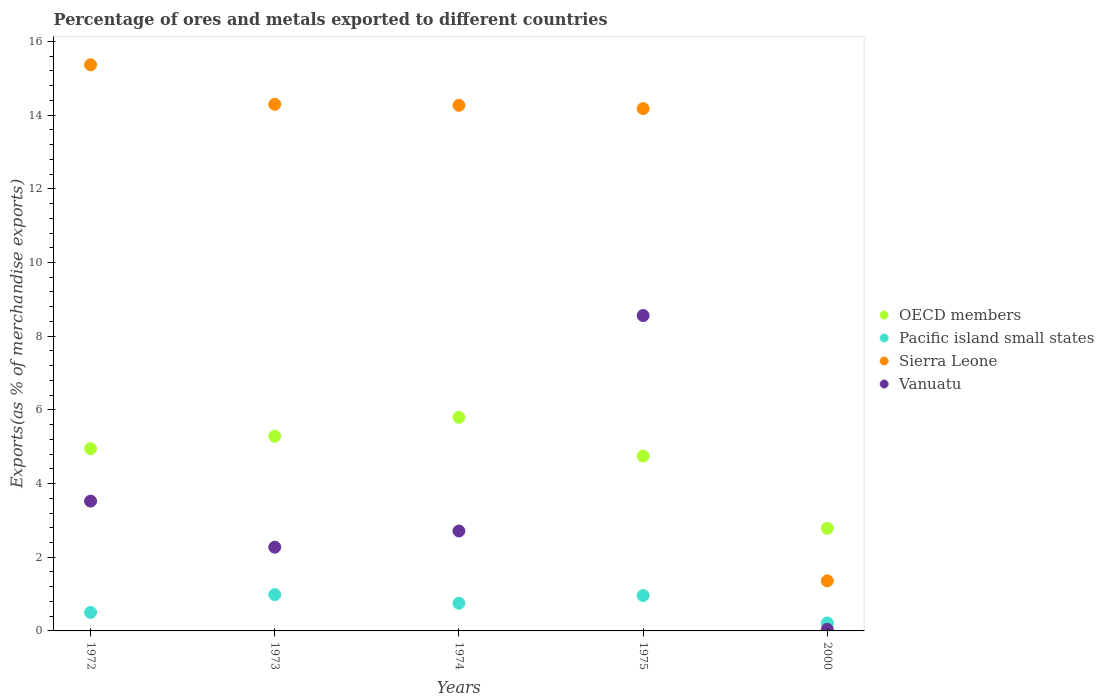How many different coloured dotlines are there?
Make the answer very short. 4. Is the number of dotlines equal to the number of legend labels?
Offer a very short reply. Yes. What is the percentage of exports to different countries in Pacific island small states in 1975?
Offer a very short reply. 0.96. Across all years, what is the maximum percentage of exports to different countries in OECD members?
Provide a succinct answer. 5.8. Across all years, what is the minimum percentage of exports to different countries in Vanuatu?
Your answer should be compact. 0.04. In which year was the percentage of exports to different countries in Vanuatu maximum?
Provide a succinct answer. 1975. In which year was the percentage of exports to different countries in OECD members minimum?
Offer a terse response. 2000. What is the total percentage of exports to different countries in Sierra Leone in the graph?
Give a very brief answer. 59.46. What is the difference between the percentage of exports to different countries in Vanuatu in 1972 and that in 1974?
Your response must be concise. 0.81. What is the difference between the percentage of exports to different countries in Vanuatu in 1975 and the percentage of exports to different countries in Sierra Leone in 2000?
Make the answer very short. 7.2. What is the average percentage of exports to different countries in Sierra Leone per year?
Your answer should be very brief. 11.89. In the year 1973, what is the difference between the percentage of exports to different countries in Vanuatu and percentage of exports to different countries in Sierra Leone?
Keep it short and to the point. -12.02. In how many years, is the percentage of exports to different countries in Pacific island small states greater than 11.6 %?
Ensure brevity in your answer.  0. What is the ratio of the percentage of exports to different countries in Sierra Leone in 1973 to that in 1974?
Give a very brief answer. 1. Is the percentage of exports to different countries in Pacific island small states in 1973 less than that in 1974?
Your answer should be very brief. No. What is the difference between the highest and the second highest percentage of exports to different countries in Vanuatu?
Offer a very short reply. 5.04. What is the difference between the highest and the lowest percentage of exports to different countries in Pacific island small states?
Keep it short and to the point. 0.77. Is the sum of the percentage of exports to different countries in Pacific island small states in 1973 and 1974 greater than the maximum percentage of exports to different countries in Vanuatu across all years?
Give a very brief answer. No. Is the percentage of exports to different countries in Pacific island small states strictly greater than the percentage of exports to different countries in Sierra Leone over the years?
Keep it short and to the point. No. Is the percentage of exports to different countries in OECD members strictly less than the percentage of exports to different countries in Pacific island small states over the years?
Provide a short and direct response. No. How many dotlines are there?
Provide a short and direct response. 4. How many years are there in the graph?
Give a very brief answer. 5. What is the difference between two consecutive major ticks on the Y-axis?
Make the answer very short. 2. What is the title of the graph?
Provide a succinct answer. Percentage of ores and metals exported to different countries. Does "Pacific island small states" appear as one of the legend labels in the graph?
Keep it short and to the point. Yes. What is the label or title of the X-axis?
Your answer should be compact. Years. What is the label or title of the Y-axis?
Offer a terse response. Exports(as % of merchandise exports). What is the Exports(as % of merchandise exports) in OECD members in 1972?
Your answer should be compact. 4.95. What is the Exports(as % of merchandise exports) in Pacific island small states in 1972?
Give a very brief answer. 0.5. What is the Exports(as % of merchandise exports) of Sierra Leone in 1972?
Your answer should be compact. 15.37. What is the Exports(as % of merchandise exports) of Vanuatu in 1972?
Offer a very short reply. 3.52. What is the Exports(as % of merchandise exports) of OECD members in 1973?
Ensure brevity in your answer.  5.28. What is the Exports(as % of merchandise exports) in Pacific island small states in 1973?
Your response must be concise. 0.99. What is the Exports(as % of merchandise exports) in Sierra Leone in 1973?
Make the answer very short. 14.29. What is the Exports(as % of merchandise exports) of Vanuatu in 1973?
Make the answer very short. 2.27. What is the Exports(as % of merchandise exports) of OECD members in 1974?
Give a very brief answer. 5.8. What is the Exports(as % of merchandise exports) of Pacific island small states in 1974?
Your response must be concise. 0.75. What is the Exports(as % of merchandise exports) of Sierra Leone in 1974?
Provide a short and direct response. 14.27. What is the Exports(as % of merchandise exports) in Vanuatu in 1974?
Ensure brevity in your answer.  2.71. What is the Exports(as % of merchandise exports) in OECD members in 1975?
Ensure brevity in your answer.  4.74. What is the Exports(as % of merchandise exports) of Pacific island small states in 1975?
Provide a short and direct response. 0.96. What is the Exports(as % of merchandise exports) in Sierra Leone in 1975?
Provide a succinct answer. 14.18. What is the Exports(as % of merchandise exports) in Vanuatu in 1975?
Offer a very short reply. 8.56. What is the Exports(as % of merchandise exports) of OECD members in 2000?
Provide a short and direct response. 2.78. What is the Exports(as % of merchandise exports) in Pacific island small states in 2000?
Make the answer very short. 0.22. What is the Exports(as % of merchandise exports) in Sierra Leone in 2000?
Ensure brevity in your answer.  1.36. What is the Exports(as % of merchandise exports) in Vanuatu in 2000?
Your answer should be compact. 0.04. Across all years, what is the maximum Exports(as % of merchandise exports) of OECD members?
Offer a terse response. 5.8. Across all years, what is the maximum Exports(as % of merchandise exports) in Pacific island small states?
Ensure brevity in your answer.  0.99. Across all years, what is the maximum Exports(as % of merchandise exports) in Sierra Leone?
Your response must be concise. 15.37. Across all years, what is the maximum Exports(as % of merchandise exports) of Vanuatu?
Your answer should be compact. 8.56. Across all years, what is the minimum Exports(as % of merchandise exports) in OECD members?
Keep it short and to the point. 2.78. Across all years, what is the minimum Exports(as % of merchandise exports) of Pacific island small states?
Offer a terse response. 0.22. Across all years, what is the minimum Exports(as % of merchandise exports) in Sierra Leone?
Make the answer very short. 1.36. Across all years, what is the minimum Exports(as % of merchandise exports) in Vanuatu?
Offer a terse response. 0.04. What is the total Exports(as % of merchandise exports) of OECD members in the graph?
Give a very brief answer. 23.56. What is the total Exports(as % of merchandise exports) in Pacific island small states in the graph?
Offer a terse response. 3.41. What is the total Exports(as % of merchandise exports) in Sierra Leone in the graph?
Your response must be concise. 59.46. What is the total Exports(as % of merchandise exports) of Vanuatu in the graph?
Provide a succinct answer. 17.11. What is the difference between the Exports(as % of merchandise exports) in OECD members in 1972 and that in 1973?
Your response must be concise. -0.34. What is the difference between the Exports(as % of merchandise exports) in Pacific island small states in 1972 and that in 1973?
Keep it short and to the point. -0.48. What is the difference between the Exports(as % of merchandise exports) of Sierra Leone in 1972 and that in 1973?
Keep it short and to the point. 1.07. What is the difference between the Exports(as % of merchandise exports) in Vanuatu in 1972 and that in 1973?
Offer a terse response. 1.25. What is the difference between the Exports(as % of merchandise exports) of OECD members in 1972 and that in 1974?
Keep it short and to the point. -0.85. What is the difference between the Exports(as % of merchandise exports) of Pacific island small states in 1972 and that in 1974?
Provide a short and direct response. -0.25. What is the difference between the Exports(as % of merchandise exports) in Sierra Leone in 1972 and that in 1974?
Provide a succinct answer. 1.1. What is the difference between the Exports(as % of merchandise exports) of Vanuatu in 1972 and that in 1974?
Provide a short and direct response. 0.81. What is the difference between the Exports(as % of merchandise exports) of OECD members in 1972 and that in 1975?
Your answer should be very brief. 0.2. What is the difference between the Exports(as % of merchandise exports) in Pacific island small states in 1972 and that in 1975?
Your response must be concise. -0.46. What is the difference between the Exports(as % of merchandise exports) in Sierra Leone in 1972 and that in 1975?
Offer a very short reply. 1.19. What is the difference between the Exports(as % of merchandise exports) in Vanuatu in 1972 and that in 1975?
Ensure brevity in your answer.  -5.04. What is the difference between the Exports(as % of merchandise exports) in OECD members in 1972 and that in 2000?
Offer a very short reply. 2.16. What is the difference between the Exports(as % of merchandise exports) of Pacific island small states in 1972 and that in 2000?
Ensure brevity in your answer.  0.29. What is the difference between the Exports(as % of merchandise exports) of Sierra Leone in 1972 and that in 2000?
Offer a very short reply. 14.01. What is the difference between the Exports(as % of merchandise exports) of Vanuatu in 1972 and that in 2000?
Your answer should be very brief. 3.48. What is the difference between the Exports(as % of merchandise exports) of OECD members in 1973 and that in 1974?
Give a very brief answer. -0.51. What is the difference between the Exports(as % of merchandise exports) of Pacific island small states in 1973 and that in 1974?
Provide a succinct answer. 0.23. What is the difference between the Exports(as % of merchandise exports) in Sierra Leone in 1973 and that in 1974?
Your answer should be very brief. 0.03. What is the difference between the Exports(as % of merchandise exports) of Vanuatu in 1973 and that in 1974?
Give a very brief answer. -0.44. What is the difference between the Exports(as % of merchandise exports) of OECD members in 1973 and that in 1975?
Keep it short and to the point. 0.54. What is the difference between the Exports(as % of merchandise exports) in Pacific island small states in 1973 and that in 1975?
Provide a succinct answer. 0.02. What is the difference between the Exports(as % of merchandise exports) in Sierra Leone in 1973 and that in 1975?
Keep it short and to the point. 0.12. What is the difference between the Exports(as % of merchandise exports) in Vanuatu in 1973 and that in 1975?
Your answer should be compact. -6.29. What is the difference between the Exports(as % of merchandise exports) of OECD members in 1973 and that in 2000?
Keep it short and to the point. 2.5. What is the difference between the Exports(as % of merchandise exports) in Pacific island small states in 1973 and that in 2000?
Make the answer very short. 0.77. What is the difference between the Exports(as % of merchandise exports) in Sierra Leone in 1973 and that in 2000?
Give a very brief answer. 12.94. What is the difference between the Exports(as % of merchandise exports) in Vanuatu in 1973 and that in 2000?
Give a very brief answer. 2.23. What is the difference between the Exports(as % of merchandise exports) of OECD members in 1974 and that in 1975?
Ensure brevity in your answer.  1.05. What is the difference between the Exports(as % of merchandise exports) in Pacific island small states in 1974 and that in 1975?
Offer a very short reply. -0.21. What is the difference between the Exports(as % of merchandise exports) in Sierra Leone in 1974 and that in 1975?
Offer a terse response. 0.09. What is the difference between the Exports(as % of merchandise exports) in Vanuatu in 1974 and that in 1975?
Your response must be concise. -5.85. What is the difference between the Exports(as % of merchandise exports) of OECD members in 1974 and that in 2000?
Give a very brief answer. 3.01. What is the difference between the Exports(as % of merchandise exports) of Pacific island small states in 1974 and that in 2000?
Your answer should be compact. 0.53. What is the difference between the Exports(as % of merchandise exports) in Sierra Leone in 1974 and that in 2000?
Your answer should be very brief. 12.91. What is the difference between the Exports(as % of merchandise exports) of Vanuatu in 1974 and that in 2000?
Provide a succinct answer. 2.67. What is the difference between the Exports(as % of merchandise exports) of OECD members in 1975 and that in 2000?
Offer a terse response. 1.96. What is the difference between the Exports(as % of merchandise exports) of Pacific island small states in 1975 and that in 2000?
Your response must be concise. 0.74. What is the difference between the Exports(as % of merchandise exports) of Sierra Leone in 1975 and that in 2000?
Provide a short and direct response. 12.82. What is the difference between the Exports(as % of merchandise exports) of Vanuatu in 1975 and that in 2000?
Keep it short and to the point. 8.52. What is the difference between the Exports(as % of merchandise exports) of OECD members in 1972 and the Exports(as % of merchandise exports) of Pacific island small states in 1973?
Your answer should be very brief. 3.96. What is the difference between the Exports(as % of merchandise exports) in OECD members in 1972 and the Exports(as % of merchandise exports) in Sierra Leone in 1973?
Keep it short and to the point. -9.35. What is the difference between the Exports(as % of merchandise exports) of OECD members in 1972 and the Exports(as % of merchandise exports) of Vanuatu in 1973?
Offer a terse response. 2.67. What is the difference between the Exports(as % of merchandise exports) of Pacific island small states in 1972 and the Exports(as % of merchandise exports) of Sierra Leone in 1973?
Give a very brief answer. -13.79. What is the difference between the Exports(as % of merchandise exports) of Pacific island small states in 1972 and the Exports(as % of merchandise exports) of Vanuatu in 1973?
Provide a short and direct response. -1.77. What is the difference between the Exports(as % of merchandise exports) in Sierra Leone in 1972 and the Exports(as % of merchandise exports) in Vanuatu in 1973?
Offer a very short reply. 13.09. What is the difference between the Exports(as % of merchandise exports) in OECD members in 1972 and the Exports(as % of merchandise exports) in Pacific island small states in 1974?
Give a very brief answer. 4.2. What is the difference between the Exports(as % of merchandise exports) of OECD members in 1972 and the Exports(as % of merchandise exports) of Sierra Leone in 1974?
Your response must be concise. -9.32. What is the difference between the Exports(as % of merchandise exports) in OECD members in 1972 and the Exports(as % of merchandise exports) in Vanuatu in 1974?
Keep it short and to the point. 2.23. What is the difference between the Exports(as % of merchandise exports) in Pacific island small states in 1972 and the Exports(as % of merchandise exports) in Sierra Leone in 1974?
Your response must be concise. -13.77. What is the difference between the Exports(as % of merchandise exports) of Pacific island small states in 1972 and the Exports(as % of merchandise exports) of Vanuatu in 1974?
Provide a short and direct response. -2.21. What is the difference between the Exports(as % of merchandise exports) of Sierra Leone in 1972 and the Exports(as % of merchandise exports) of Vanuatu in 1974?
Offer a very short reply. 12.65. What is the difference between the Exports(as % of merchandise exports) of OECD members in 1972 and the Exports(as % of merchandise exports) of Pacific island small states in 1975?
Provide a succinct answer. 3.99. What is the difference between the Exports(as % of merchandise exports) of OECD members in 1972 and the Exports(as % of merchandise exports) of Sierra Leone in 1975?
Provide a short and direct response. -9.23. What is the difference between the Exports(as % of merchandise exports) of OECD members in 1972 and the Exports(as % of merchandise exports) of Vanuatu in 1975?
Keep it short and to the point. -3.61. What is the difference between the Exports(as % of merchandise exports) of Pacific island small states in 1972 and the Exports(as % of merchandise exports) of Sierra Leone in 1975?
Your answer should be compact. -13.68. What is the difference between the Exports(as % of merchandise exports) in Pacific island small states in 1972 and the Exports(as % of merchandise exports) in Vanuatu in 1975?
Offer a very short reply. -8.06. What is the difference between the Exports(as % of merchandise exports) in Sierra Leone in 1972 and the Exports(as % of merchandise exports) in Vanuatu in 1975?
Provide a short and direct response. 6.81. What is the difference between the Exports(as % of merchandise exports) in OECD members in 1972 and the Exports(as % of merchandise exports) in Pacific island small states in 2000?
Your answer should be very brief. 4.73. What is the difference between the Exports(as % of merchandise exports) of OECD members in 1972 and the Exports(as % of merchandise exports) of Sierra Leone in 2000?
Ensure brevity in your answer.  3.59. What is the difference between the Exports(as % of merchandise exports) of OECD members in 1972 and the Exports(as % of merchandise exports) of Vanuatu in 2000?
Make the answer very short. 4.9. What is the difference between the Exports(as % of merchandise exports) of Pacific island small states in 1972 and the Exports(as % of merchandise exports) of Sierra Leone in 2000?
Your answer should be compact. -0.86. What is the difference between the Exports(as % of merchandise exports) of Pacific island small states in 1972 and the Exports(as % of merchandise exports) of Vanuatu in 2000?
Give a very brief answer. 0.46. What is the difference between the Exports(as % of merchandise exports) of Sierra Leone in 1972 and the Exports(as % of merchandise exports) of Vanuatu in 2000?
Provide a succinct answer. 15.32. What is the difference between the Exports(as % of merchandise exports) in OECD members in 1973 and the Exports(as % of merchandise exports) in Pacific island small states in 1974?
Keep it short and to the point. 4.53. What is the difference between the Exports(as % of merchandise exports) of OECD members in 1973 and the Exports(as % of merchandise exports) of Sierra Leone in 1974?
Provide a succinct answer. -8.98. What is the difference between the Exports(as % of merchandise exports) in OECD members in 1973 and the Exports(as % of merchandise exports) in Vanuatu in 1974?
Provide a short and direct response. 2.57. What is the difference between the Exports(as % of merchandise exports) in Pacific island small states in 1973 and the Exports(as % of merchandise exports) in Sierra Leone in 1974?
Your answer should be very brief. -13.28. What is the difference between the Exports(as % of merchandise exports) of Pacific island small states in 1973 and the Exports(as % of merchandise exports) of Vanuatu in 1974?
Provide a succinct answer. -1.73. What is the difference between the Exports(as % of merchandise exports) in Sierra Leone in 1973 and the Exports(as % of merchandise exports) in Vanuatu in 1974?
Give a very brief answer. 11.58. What is the difference between the Exports(as % of merchandise exports) of OECD members in 1973 and the Exports(as % of merchandise exports) of Pacific island small states in 1975?
Ensure brevity in your answer.  4.32. What is the difference between the Exports(as % of merchandise exports) of OECD members in 1973 and the Exports(as % of merchandise exports) of Sierra Leone in 1975?
Ensure brevity in your answer.  -8.89. What is the difference between the Exports(as % of merchandise exports) in OECD members in 1973 and the Exports(as % of merchandise exports) in Vanuatu in 1975?
Keep it short and to the point. -3.28. What is the difference between the Exports(as % of merchandise exports) in Pacific island small states in 1973 and the Exports(as % of merchandise exports) in Sierra Leone in 1975?
Your response must be concise. -13.19. What is the difference between the Exports(as % of merchandise exports) in Pacific island small states in 1973 and the Exports(as % of merchandise exports) in Vanuatu in 1975?
Your answer should be compact. -7.58. What is the difference between the Exports(as % of merchandise exports) in Sierra Leone in 1973 and the Exports(as % of merchandise exports) in Vanuatu in 1975?
Ensure brevity in your answer.  5.73. What is the difference between the Exports(as % of merchandise exports) in OECD members in 1973 and the Exports(as % of merchandise exports) in Pacific island small states in 2000?
Your answer should be compact. 5.07. What is the difference between the Exports(as % of merchandise exports) of OECD members in 1973 and the Exports(as % of merchandise exports) of Sierra Leone in 2000?
Your answer should be very brief. 3.92. What is the difference between the Exports(as % of merchandise exports) of OECD members in 1973 and the Exports(as % of merchandise exports) of Vanuatu in 2000?
Your response must be concise. 5.24. What is the difference between the Exports(as % of merchandise exports) in Pacific island small states in 1973 and the Exports(as % of merchandise exports) in Sierra Leone in 2000?
Your answer should be very brief. -0.37. What is the difference between the Exports(as % of merchandise exports) of Pacific island small states in 1973 and the Exports(as % of merchandise exports) of Vanuatu in 2000?
Give a very brief answer. 0.94. What is the difference between the Exports(as % of merchandise exports) of Sierra Leone in 1973 and the Exports(as % of merchandise exports) of Vanuatu in 2000?
Provide a succinct answer. 14.25. What is the difference between the Exports(as % of merchandise exports) of OECD members in 1974 and the Exports(as % of merchandise exports) of Pacific island small states in 1975?
Provide a succinct answer. 4.84. What is the difference between the Exports(as % of merchandise exports) in OECD members in 1974 and the Exports(as % of merchandise exports) in Sierra Leone in 1975?
Offer a very short reply. -8.38. What is the difference between the Exports(as % of merchandise exports) in OECD members in 1974 and the Exports(as % of merchandise exports) in Vanuatu in 1975?
Provide a succinct answer. -2.76. What is the difference between the Exports(as % of merchandise exports) of Pacific island small states in 1974 and the Exports(as % of merchandise exports) of Sierra Leone in 1975?
Ensure brevity in your answer.  -13.43. What is the difference between the Exports(as % of merchandise exports) of Pacific island small states in 1974 and the Exports(as % of merchandise exports) of Vanuatu in 1975?
Ensure brevity in your answer.  -7.81. What is the difference between the Exports(as % of merchandise exports) in Sierra Leone in 1974 and the Exports(as % of merchandise exports) in Vanuatu in 1975?
Make the answer very short. 5.71. What is the difference between the Exports(as % of merchandise exports) in OECD members in 1974 and the Exports(as % of merchandise exports) in Pacific island small states in 2000?
Offer a very short reply. 5.58. What is the difference between the Exports(as % of merchandise exports) of OECD members in 1974 and the Exports(as % of merchandise exports) of Sierra Leone in 2000?
Keep it short and to the point. 4.44. What is the difference between the Exports(as % of merchandise exports) in OECD members in 1974 and the Exports(as % of merchandise exports) in Vanuatu in 2000?
Provide a succinct answer. 5.75. What is the difference between the Exports(as % of merchandise exports) of Pacific island small states in 1974 and the Exports(as % of merchandise exports) of Sierra Leone in 2000?
Give a very brief answer. -0.61. What is the difference between the Exports(as % of merchandise exports) of Pacific island small states in 1974 and the Exports(as % of merchandise exports) of Vanuatu in 2000?
Keep it short and to the point. 0.71. What is the difference between the Exports(as % of merchandise exports) in Sierra Leone in 1974 and the Exports(as % of merchandise exports) in Vanuatu in 2000?
Offer a very short reply. 14.22. What is the difference between the Exports(as % of merchandise exports) of OECD members in 1975 and the Exports(as % of merchandise exports) of Pacific island small states in 2000?
Ensure brevity in your answer.  4.53. What is the difference between the Exports(as % of merchandise exports) in OECD members in 1975 and the Exports(as % of merchandise exports) in Sierra Leone in 2000?
Offer a terse response. 3.39. What is the difference between the Exports(as % of merchandise exports) of OECD members in 1975 and the Exports(as % of merchandise exports) of Vanuatu in 2000?
Provide a short and direct response. 4.7. What is the difference between the Exports(as % of merchandise exports) in Pacific island small states in 1975 and the Exports(as % of merchandise exports) in Sierra Leone in 2000?
Make the answer very short. -0.4. What is the difference between the Exports(as % of merchandise exports) of Pacific island small states in 1975 and the Exports(as % of merchandise exports) of Vanuatu in 2000?
Make the answer very short. 0.92. What is the difference between the Exports(as % of merchandise exports) of Sierra Leone in 1975 and the Exports(as % of merchandise exports) of Vanuatu in 2000?
Ensure brevity in your answer.  14.13. What is the average Exports(as % of merchandise exports) of OECD members per year?
Make the answer very short. 4.71. What is the average Exports(as % of merchandise exports) in Pacific island small states per year?
Offer a terse response. 0.68. What is the average Exports(as % of merchandise exports) in Sierra Leone per year?
Provide a short and direct response. 11.89. What is the average Exports(as % of merchandise exports) of Vanuatu per year?
Your answer should be compact. 3.42. In the year 1972, what is the difference between the Exports(as % of merchandise exports) of OECD members and Exports(as % of merchandise exports) of Pacific island small states?
Make the answer very short. 4.44. In the year 1972, what is the difference between the Exports(as % of merchandise exports) of OECD members and Exports(as % of merchandise exports) of Sierra Leone?
Your answer should be very brief. -10.42. In the year 1972, what is the difference between the Exports(as % of merchandise exports) in OECD members and Exports(as % of merchandise exports) in Vanuatu?
Your answer should be very brief. 1.42. In the year 1972, what is the difference between the Exports(as % of merchandise exports) in Pacific island small states and Exports(as % of merchandise exports) in Sierra Leone?
Offer a very short reply. -14.86. In the year 1972, what is the difference between the Exports(as % of merchandise exports) of Pacific island small states and Exports(as % of merchandise exports) of Vanuatu?
Make the answer very short. -3.02. In the year 1972, what is the difference between the Exports(as % of merchandise exports) in Sierra Leone and Exports(as % of merchandise exports) in Vanuatu?
Offer a terse response. 11.84. In the year 1973, what is the difference between the Exports(as % of merchandise exports) in OECD members and Exports(as % of merchandise exports) in Pacific island small states?
Your answer should be compact. 4.3. In the year 1973, what is the difference between the Exports(as % of merchandise exports) of OECD members and Exports(as % of merchandise exports) of Sierra Leone?
Offer a very short reply. -9.01. In the year 1973, what is the difference between the Exports(as % of merchandise exports) of OECD members and Exports(as % of merchandise exports) of Vanuatu?
Provide a succinct answer. 3.01. In the year 1973, what is the difference between the Exports(as % of merchandise exports) of Pacific island small states and Exports(as % of merchandise exports) of Sierra Leone?
Ensure brevity in your answer.  -13.31. In the year 1973, what is the difference between the Exports(as % of merchandise exports) of Pacific island small states and Exports(as % of merchandise exports) of Vanuatu?
Offer a very short reply. -1.29. In the year 1973, what is the difference between the Exports(as % of merchandise exports) in Sierra Leone and Exports(as % of merchandise exports) in Vanuatu?
Your answer should be very brief. 12.02. In the year 1974, what is the difference between the Exports(as % of merchandise exports) of OECD members and Exports(as % of merchandise exports) of Pacific island small states?
Offer a very short reply. 5.05. In the year 1974, what is the difference between the Exports(as % of merchandise exports) of OECD members and Exports(as % of merchandise exports) of Sierra Leone?
Your response must be concise. -8.47. In the year 1974, what is the difference between the Exports(as % of merchandise exports) in OECD members and Exports(as % of merchandise exports) in Vanuatu?
Offer a very short reply. 3.08. In the year 1974, what is the difference between the Exports(as % of merchandise exports) of Pacific island small states and Exports(as % of merchandise exports) of Sierra Leone?
Offer a terse response. -13.52. In the year 1974, what is the difference between the Exports(as % of merchandise exports) in Pacific island small states and Exports(as % of merchandise exports) in Vanuatu?
Your answer should be very brief. -1.96. In the year 1974, what is the difference between the Exports(as % of merchandise exports) of Sierra Leone and Exports(as % of merchandise exports) of Vanuatu?
Provide a succinct answer. 11.55. In the year 1975, what is the difference between the Exports(as % of merchandise exports) of OECD members and Exports(as % of merchandise exports) of Pacific island small states?
Give a very brief answer. 3.78. In the year 1975, what is the difference between the Exports(as % of merchandise exports) in OECD members and Exports(as % of merchandise exports) in Sierra Leone?
Provide a succinct answer. -9.43. In the year 1975, what is the difference between the Exports(as % of merchandise exports) in OECD members and Exports(as % of merchandise exports) in Vanuatu?
Your answer should be compact. -3.82. In the year 1975, what is the difference between the Exports(as % of merchandise exports) of Pacific island small states and Exports(as % of merchandise exports) of Sierra Leone?
Give a very brief answer. -13.22. In the year 1975, what is the difference between the Exports(as % of merchandise exports) of Sierra Leone and Exports(as % of merchandise exports) of Vanuatu?
Your answer should be compact. 5.62. In the year 2000, what is the difference between the Exports(as % of merchandise exports) in OECD members and Exports(as % of merchandise exports) in Pacific island small states?
Your answer should be compact. 2.57. In the year 2000, what is the difference between the Exports(as % of merchandise exports) in OECD members and Exports(as % of merchandise exports) in Sierra Leone?
Your answer should be very brief. 1.43. In the year 2000, what is the difference between the Exports(as % of merchandise exports) of OECD members and Exports(as % of merchandise exports) of Vanuatu?
Your response must be concise. 2.74. In the year 2000, what is the difference between the Exports(as % of merchandise exports) of Pacific island small states and Exports(as % of merchandise exports) of Sierra Leone?
Ensure brevity in your answer.  -1.14. In the year 2000, what is the difference between the Exports(as % of merchandise exports) in Pacific island small states and Exports(as % of merchandise exports) in Vanuatu?
Your response must be concise. 0.17. In the year 2000, what is the difference between the Exports(as % of merchandise exports) in Sierra Leone and Exports(as % of merchandise exports) in Vanuatu?
Provide a succinct answer. 1.32. What is the ratio of the Exports(as % of merchandise exports) of OECD members in 1972 to that in 1973?
Your answer should be compact. 0.94. What is the ratio of the Exports(as % of merchandise exports) of Pacific island small states in 1972 to that in 1973?
Make the answer very short. 0.51. What is the ratio of the Exports(as % of merchandise exports) in Sierra Leone in 1972 to that in 1973?
Give a very brief answer. 1.07. What is the ratio of the Exports(as % of merchandise exports) in Vanuatu in 1972 to that in 1973?
Your answer should be very brief. 1.55. What is the ratio of the Exports(as % of merchandise exports) in OECD members in 1972 to that in 1974?
Make the answer very short. 0.85. What is the ratio of the Exports(as % of merchandise exports) in Pacific island small states in 1972 to that in 1974?
Provide a short and direct response. 0.67. What is the ratio of the Exports(as % of merchandise exports) of Sierra Leone in 1972 to that in 1974?
Provide a succinct answer. 1.08. What is the ratio of the Exports(as % of merchandise exports) of Vanuatu in 1972 to that in 1974?
Make the answer very short. 1.3. What is the ratio of the Exports(as % of merchandise exports) in OECD members in 1972 to that in 1975?
Make the answer very short. 1.04. What is the ratio of the Exports(as % of merchandise exports) of Pacific island small states in 1972 to that in 1975?
Provide a succinct answer. 0.52. What is the ratio of the Exports(as % of merchandise exports) of Sierra Leone in 1972 to that in 1975?
Give a very brief answer. 1.08. What is the ratio of the Exports(as % of merchandise exports) of Vanuatu in 1972 to that in 1975?
Ensure brevity in your answer.  0.41. What is the ratio of the Exports(as % of merchandise exports) in OECD members in 1972 to that in 2000?
Keep it short and to the point. 1.78. What is the ratio of the Exports(as % of merchandise exports) in Pacific island small states in 1972 to that in 2000?
Ensure brevity in your answer.  2.32. What is the ratio of the Exports(as % of merchandise exports) in Sierra Leone in 1972 to that in 2000?
Make the answer very short. 11.31. What is the ratio of the Exports(as % of merchandise exports) in Vanuatu in 1972 to that in 2000?
Your answer should be very brief. 82.1. What is the ratio of the Exports(as % of merchandise exports) in OECD members in 1973 to that in 1974?
Offer a terse response. 0.91. What is the ratio of the Exports(as % of merchandise exports) of Pacific island small states in 1973 to that in 1974?
Provide a succinct answer. 1.31. What is the ratio of the Exports(as % of merchandise exports) of Vanuatu in 1973 to that in 1974?
Give a very brief answer. 0.84. What is the ratio of the Exports(as % of merchandise exports) in OECD members in 1973 to that in 1975?
Your response must be concise. 1.11. What is the ratio of the Exports(as % of merchandise exports) of Pacific island small states in 1973 to that in 1975?
Your answer should be compact. 1.03. What is the ratio of the Exports(as % of merchandise exports) of Sierra Leone in 1973 to that in 1975?
Make the answer very short. 1.01. What is the ratio of the Exports(as % of merchandise exports) of Vanuatu in 1973 to that in 1975?
Ensure brevity in your answer.  0.27. What is the ratio of the Exports(as % of merchandise exports) of OECD members in 1973 to that in 2000?
Your response must be concise. 1.9. What is the ratio of the Exports(as % of merchandise exports) in Pacific island small states in 1973 to that in 2000?
Provide a short and direct response. 4.55. What is the ratio of the Exports(as % of merchandise exports) in Sierra Leone in 1973 to that in 2000?
Provide a short and direct response. 10.53. What is the ratio of the Exports(as % of merchandise exports) of Vanuatu in 1973 to that in 2000?
Your answer should be compact. 52.96. What is the ratio of the Exports(as % of merchandise exports) in OECD members in 1974 to that in 1975?
Provide a succinct answer. 1.22. What is the ratio of the Exports(as % of merchandise exports) in Pacific island small states in 1974 to that in 1975?
Give a very brief answer. 0.78. What is the ratio of the Exports(as % of merchandise exports) in Sierra Leone in 1974 to that in 1975?
Keep it short and to the point. 1.01. What is the ratio of the Exports(as % of merchandise exports) of Vanuatu in 1974 to that in 1975?
Ensure brevity in your answer.  0.32. What is the ratio of the Exports(as % of merchandise exports) in OECD members in 1974 to that in 2000?
Make the answer very short. 2.08. What is the ratio of the Exports(as % of merchandise exports) in Pacific island small states in 1974 to that in 2000?
Make the answer very short. 3.47. What is the ratio of the Exports(as % of merchandise exports) in Sierra Leone in 1974 to that in 2000?
Your answer should be compact. 10.51. What is the ratio of the Exports(as % of merchandise exports) of Vanuatu in 1974 to that in 2000?
Give a very brief answer. 63.2. What is the ratio of the Exports(as % of merchandise exports) in OECD members in 1975 to that in 2000?
Provide a succinct answer. 1.7. What is the ratio of the Exports(as % of merchandise exports) of Pacific island small states in 1975 to that in 2000?
Keep it short and to the point. 4.44. What is the ratio of the Exports(as % of merchandise exports) of Sierra Leone in 1975 to that in 2000?
Give a very brief answer. 10.44. What is the ratio of the Exports(as % of merchandise exports) in Vanuatu in 1975 to that in 2000?
Keep it short and to the point. 199.46. What is the difference between the highest and the second highest Exports(as % of merchandise exports) of OECD members?
Ensure brevity in your answer.  0.51. What is the difference between the highest and the second highest Exports(as % of merchandise exports) in Pacific island small states?
Keep it short and to the point. 0.02. What is the difference between the highest and the second highest Exports(as % of merchandise exports) of Sierra Leone?
Your answer should be very brief. 1.07. What is the difference between the highest and the second highest Exports(as % of merchandise exports) in Vanuatu?
Ensure brevity in your answer.  5.04. What is the difference between the highest and the lowest Exports(as % of merchandise exports) of OECD members?
Your response must be concise. 3.01. What is the difference between the highest and the lowest Exports(as % of merchandise exports) in Pacific island small states?
Offer a very short reply. 0.77. What is the difference between the highest and the lowest Exports(as % of merchandise exports) of Sierra Leone?
Keep it short and to the point. 14.01. What is the difference between the highest and the lowest Exports(as % of merchandise exports) of Vanuatu?
Give a very brief answer. 8.52. 